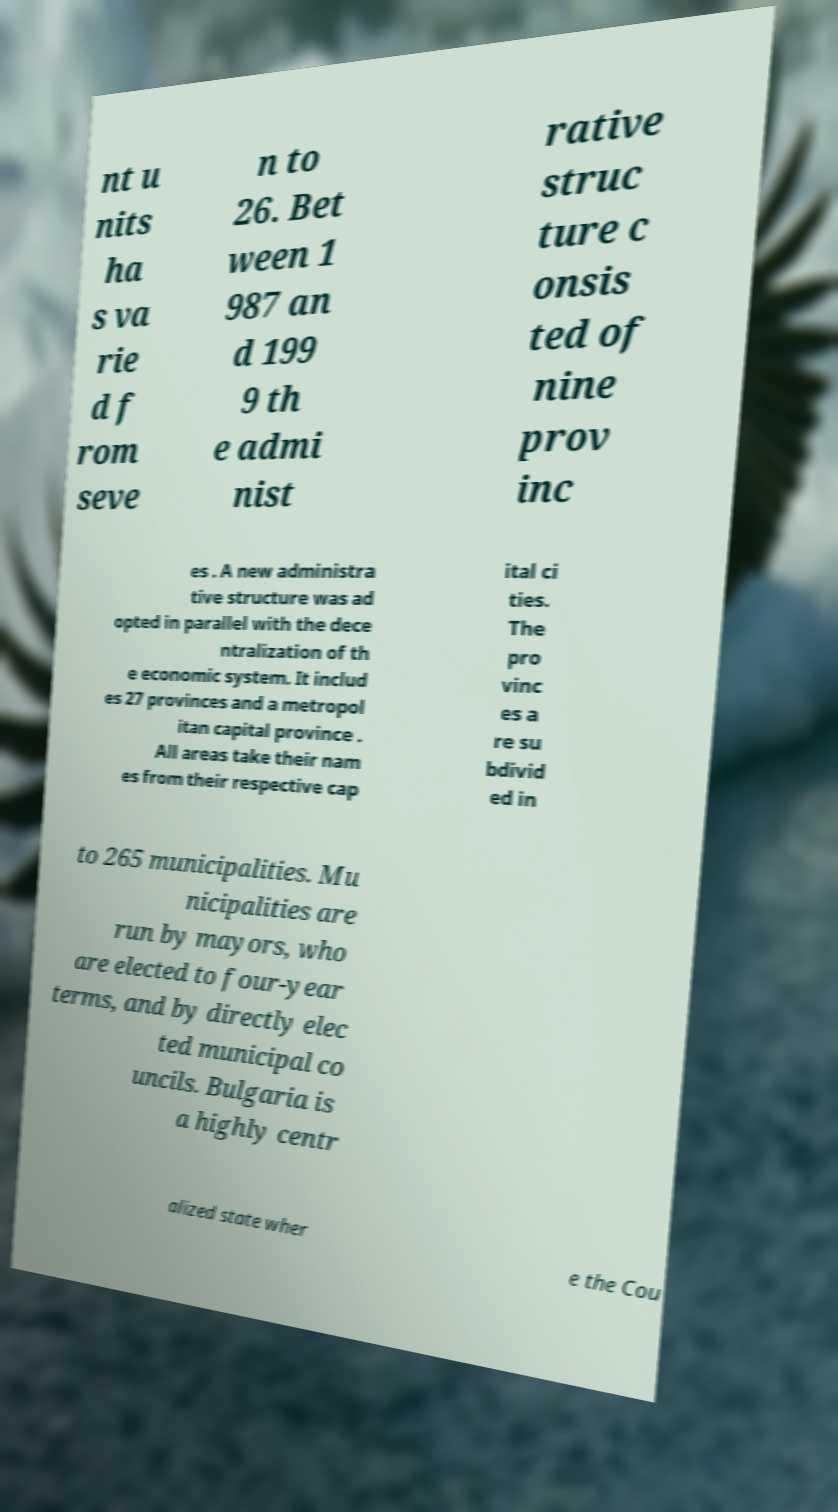What messages or text are displayed in this image? I need them in a readable, typed format. nt u nits ha s va rie d f rom seve n to 26. Bet ween 1 987 an d 199 9 th e admi nist rative struc ture c onsis ted of nine prov inc es . A new administra tive structure was ad opted in parallel with the dece ntralization of th e economic system. It includ es 27 provinces and a metropol itan capital province . All areas take their nam es from their respective cap ital ci ties. The pro vinc es a re su bdivid ed in to 265 municipalities. Mu nicipalities are run by mayors, who are elected to four-year terms, and by directly elec ted municipal co uncils. Bulgaria is a highly centr alized state wher e the Cou 